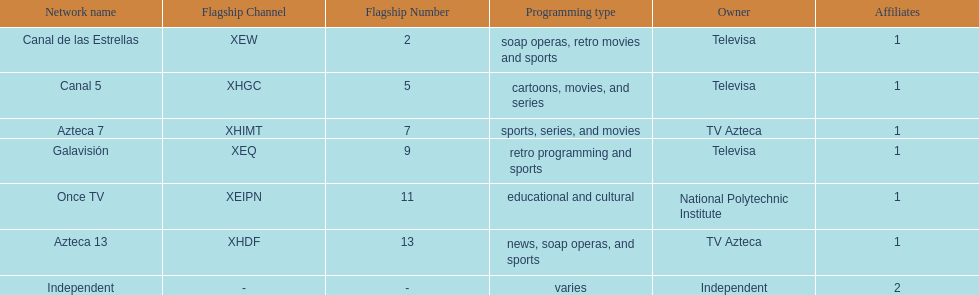What is the total number of affiliates among all the networks? 8. 